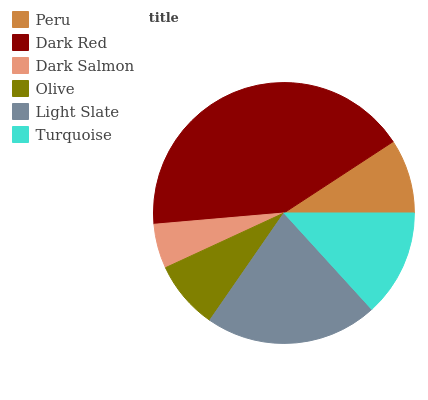Is Dark Salmon the minimum?
Answer yes or no. Yes. Is Dark Red the maximum?
Answer yes or no. Yes. Is Dark Red the minimum?
Answer yes or no. No. Is Dark Salmon the maximum?
Answer yes or no. No. Is Dark Red greater than Dark Salmon?
Answer yes or no. Yes. Is Dark Salmon less than Dark Red?
Answer yes or no. Yes. Is Dark Salmon greater than Dark Red?
Answer yes or no. No. Is Dark Red less than Dark Salmon?
Answer yes or no. No. Is Turquoise the high median?
Answer yes or no. Yes. Is Peru the low median?
Answer yes or no. Yes. Is Olive the high median?
Answer yes or no. No. Is Dark Red the low median?
Answer yes or no. No. 